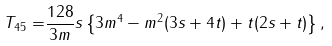<formula> <loc_0><loc_0><loc_500><loc_500>T _ { 4 5 } = & \frac { 1 2 8 } { 3 m } s \left \{ 3 m ^ { 4 } - m ^ { 2 } ( 3 s + 4 t ) + t ( 2 s + t ) \right \} ,</formula> 